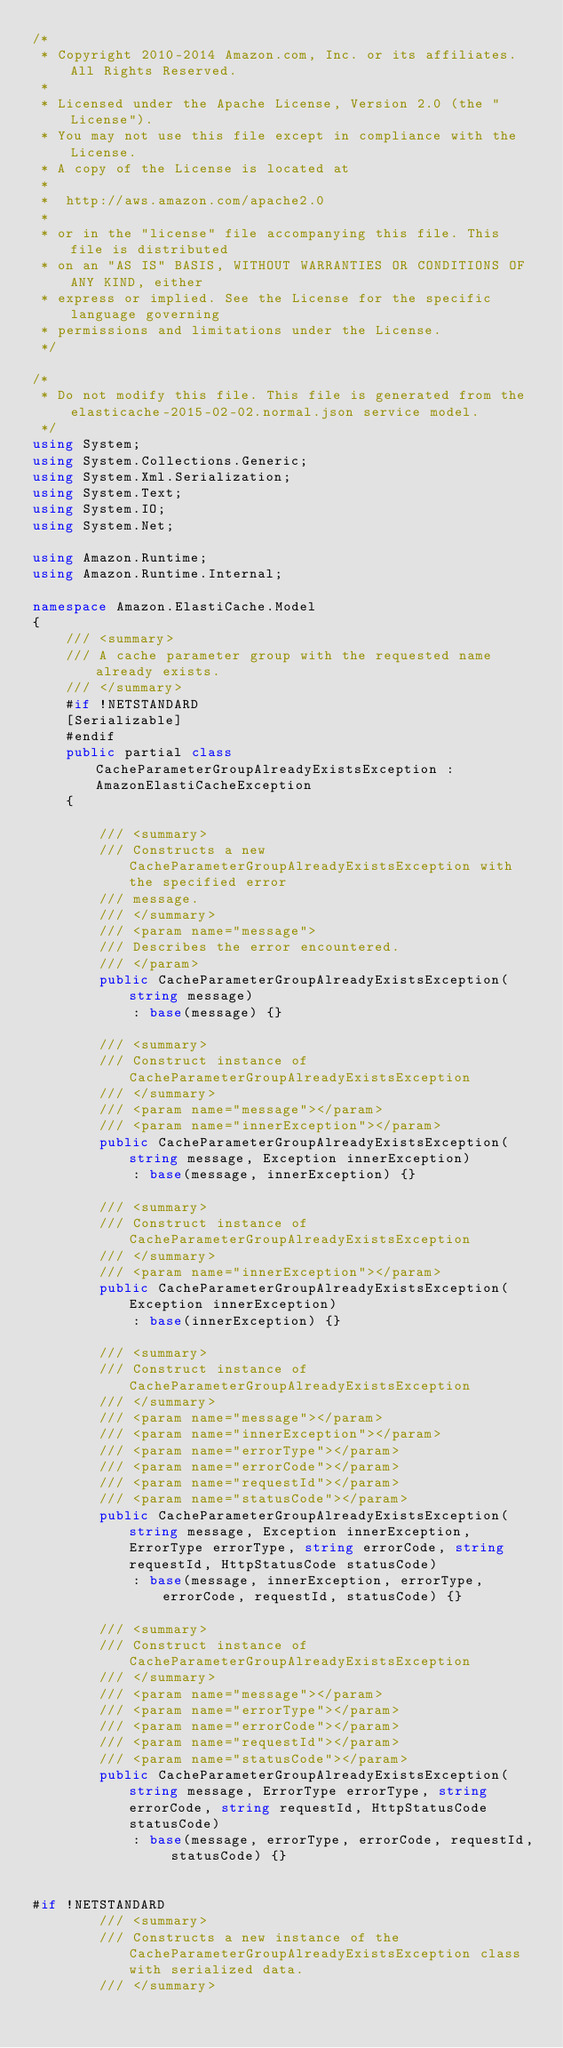<code> <loc_0><loc_0><loc_500><loc_500><_C#_>/*
 * Copyright 2010-2014 Amazon.com, Inc. or its affiliates. All Rights Reserved.
 * 
 * Licensed under the Apache License, Version 2.0 (the "License").
 * You may not use this file except in compliance with the License.
 * A copy of the License is located at
 * 
 *  http://aws.amazon.com/apache2.0
 * 
 * or in the "license" file accompanying this file. This file is distributed
 * on an "AS IS" BASIS, WITHOUT WARRANTIES OR CONDITIONS OF ANY KIND, either
 * express or implied. See the License for the specific language governing
 * permissions and limitations under the License.
 */

/*
 * Do not modify this file. This file is generated from the elasticache-2015-02-02.normal.json service model.
 */
using System;
using System.Collections.Generic;
using System.Xml.Serialization;
using System.Text;
using System.IO;
using System.Net;

using Amazon.Runtime;
using Amazon.Runtime.Internal;

namespace Amazon.ElastiCache.Model
{
    /// <summary>
    /// A cache parameter group with the requested name already exists.
    /// </summary>
    #if !NETSTANDARD
    [Serializable]
    #endif
    public partial class CacheParameterGroupAlreadyExistsException : AmazonElastiCacheException
    {

        /// <summary>
        /// Constructs a new CacheParameterGroupAlreadyExistsException with the specified error
        /// message.
        /// </summary>
        /// <param name="message">
        /// Describes the error encountered.
        /// </param>
        public CacheParameterGroupAlreadyExistsException(string message) 
            : base(message) {}

        /// <summary>
        /// Construct instance of CacheParameterGroupAlreadyExistsException
        /// </summary>
        /// <param name="message"></param>
        /// <param name="innerException"></param>
        public CacheParameterGroupAlreadyExistsException(string message, Exception innerException) 
            : base(message, innerException) {}

        /// <summary>
        /// Construct instance of CacheParameterGroupAlreadyExistsException
        /// </summary>
        /// <param name="innerException"></param>
        public CacheParameterGroupAlreadyExistsException(Exception innerException) 
            : base(innerException) {}

        /// <summary>
        /// Construct instance of CacheParameterGroupAlreadyExistsException
        /// </summary>
        /// <param name="message"></param>
        /// <param name="innerException"></param>
        /// <param name="errorType"></param>
        /// <param name="errorCode"></param>
        /// <param name="requestId"></param>
        /// <param name="statusCode"></param>
        public CacheParameterGroupAlreadyExistsException(string message, Exception innerException, ErrorType errorType, string errorCode, string requestId, HttpStatusCode statusCode) 
            : base(message, innerException, errorType, errorCode, requestId, statusCode) {}

        /// <summary>
        /// Construct instance of CacheParameterGroupAlreadyExistsException
        /// </summary>
        /// <param name="message"></param>
        /// <param name="errorType"></param>
        /// <param name="errorCode"></param>
        /// <param name="requestId"></param>
        /// <param name="statusCode"></param>
        public CacheParameterGroupAlreadyExistsException(string message, ErrorType errorType, string errorCode, string requestId, HttpStatusCode statusCode) 
            : base(message, errorType, errorCode, requestId, statusCode) {}


#if !NETSTANDARD
        /// <summary>
        /// Constructs a new instance of the CacheParameterGroupAlreadyExistsException class with serialized data.
        /// </summary></code> 